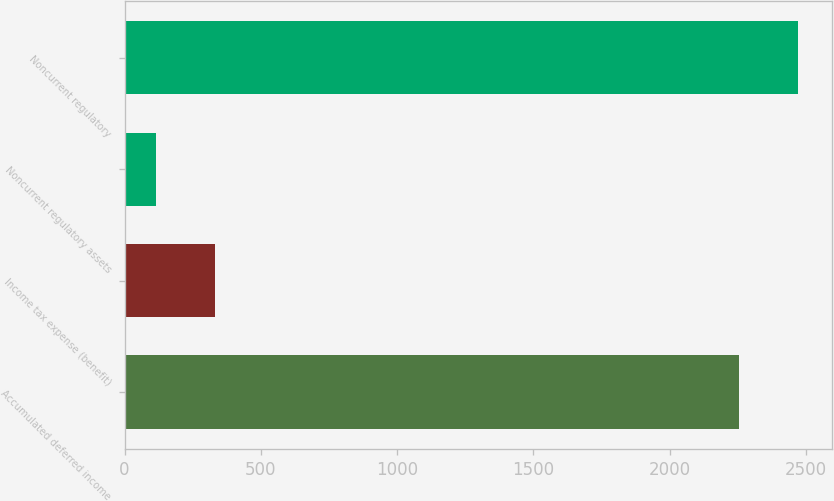<chart> <loc_0><loc_0><loc_500><loc_500><bar_chart><fcel>Accumulated deferred income<fcel>Income tax expense (benefit)<fcel>Noncurrent regulatory assets<fcel>Noncurrent regulatory<nl><fcel>2253<fcel>331.9<fcel>114<fcel>2470.9<nl></chart> 